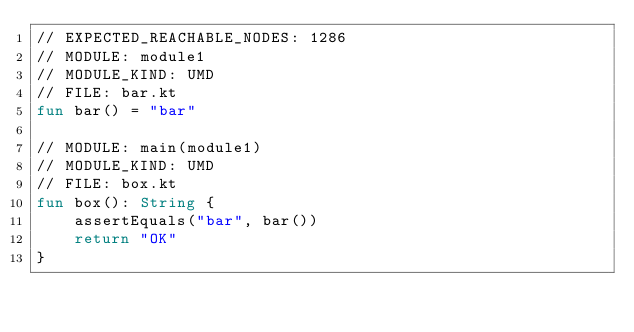<code> <loc_0><loc_0><loc_500><loc_500><_Kotlin_>// EXPECTED_REACHABLE_NODES: 1286
// MODULE: module1
// MODULE_KIND: UMD
// FILE: bar.kt
fun bar() = "bar"

// MODULE: main(module1)
// MODULE_KIND: UMD
// FILE: box.kt
fun box(): String {
    assertEquals("bar", bar())
    return "OK"
}</code> 